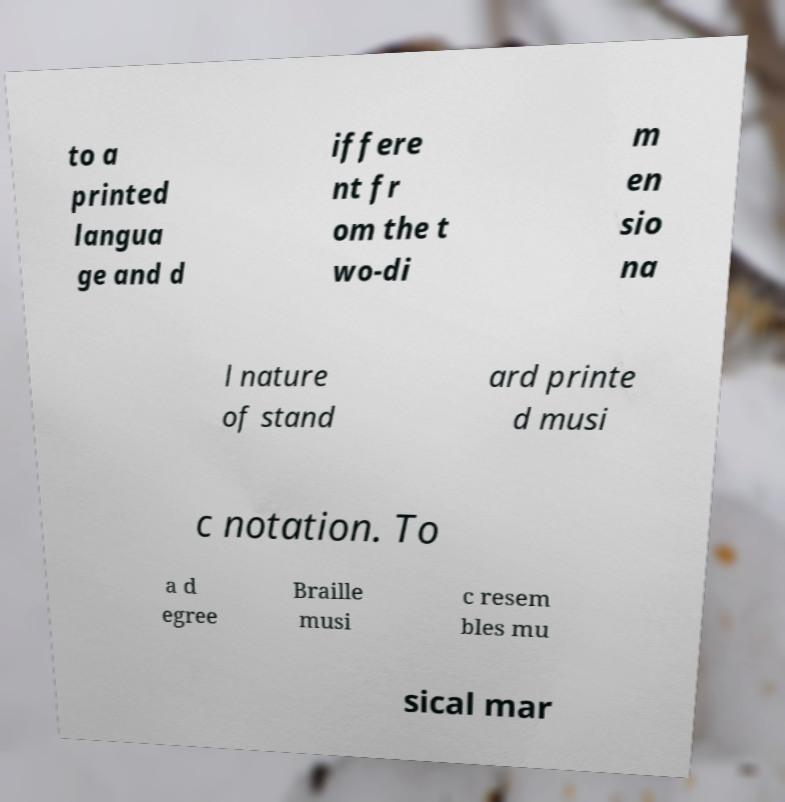Please identify and transcribe the text found in this image. to a printed langua ge and d iffere nt fr om the t wo-di m en sio na l nature of stand ard printe d musi c notation. To a d egree Braille musi c resem bles mu sical mar 